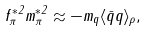<formula> <loc_0><loc_0><loc_500><loc_500>f _ { \pi } ^ { * 2 } m _ { \pi } ^ { * 2 } \approx - m _ { q } \langle \bar { q } q \rangle _ { \rho } ,</formula> 